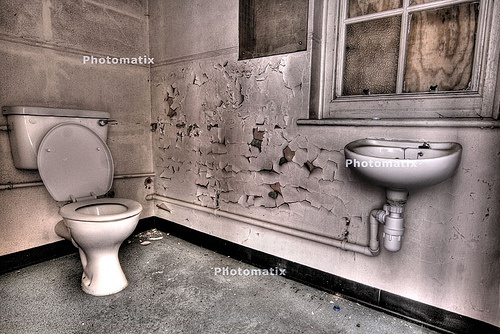Describe the objects in this image and their specific colors. I can see toilet in black, darkgray, white, and gray tones and sink in black, lightgray, darkgray, and gray tones in this image. 